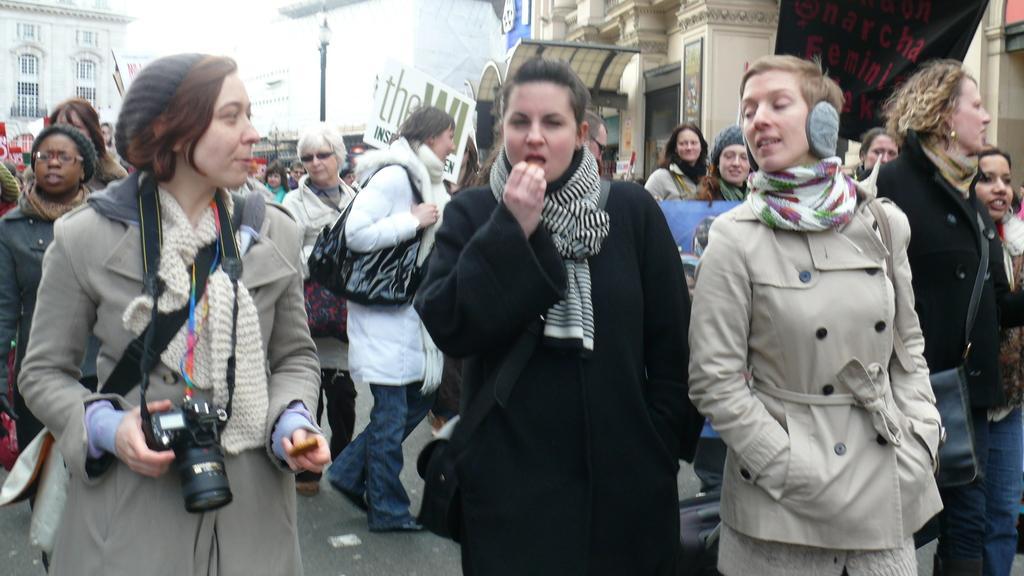In one or two sentences, can you explain what this image depicts? In this image I can see a crowd of people walking on the road. The woman who is on the left side is holding a camera and looking at the people who are beside her. In the background there are few buildings and a pole. Everyone is wearing jackets. 